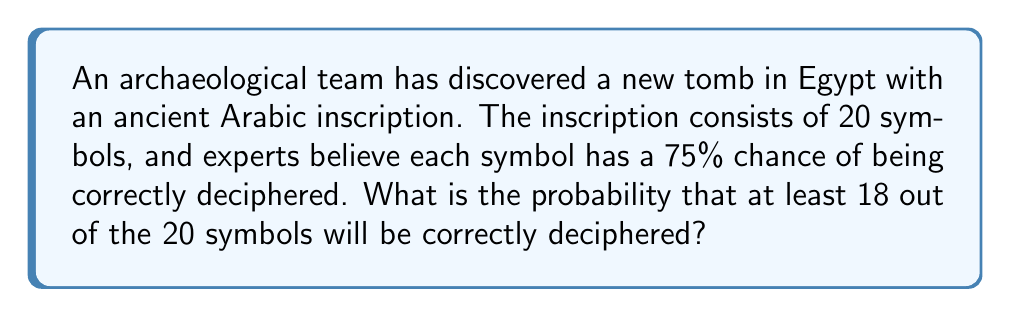Can you answer this question? To solve this problem, we'll use the binomial probability distribution, as we're dealing with a fixed number of independent trials (deciphering each symbol) with two possible outcomes (success or failure).

Let's break it down step-by-step:

1. We have $n = 20$ symbols (trials)
2. The probability of success (correctly deciphering a symbol) is $p = 0.75$
3. We want to find the probability of at least 18 successes, which means we need to calculate $P(X \geq 18)$, where $X$ is the number of correctly deciphered symbols

We can calculate this as:

$P(X \geq 18) = P(X = 18) + P(X = 19) + P(X = 20)$

Using the binomial probability formula:

$P(X = k) = \binom{n}{k} p^k (1-p)^{n-k}$

Where $\binom{n}{k}$ is the binomial coefficient, calculated as:

$\binom{n}{k} = \frac{n!}{k!(n-k)!}$

Let's calculate each probability:

For $k = 18$:
$$P(X = 18) = \binom{20}{18} (0.75)^{18} (0.25)^2 = 190 \times 0.75^{18} \times 0.25^2 \approx 0.2252$$

For $k = 19$:
$$P(X = 19) = \binom{20}{19} (0.75)^{19} (0.25)^1 = 20 \times 0.75^{19} \times 0.25 \approx 0.1001$$

For $k = 20$:
$$P(X = 20) = \binom{20}{20} (0.75)^{20} (0.25)^0 = 1 \times 0.75^{20} \approx 0.0032$$

Now, we sum these probabilities:

$P(X \geq 18) = 0.2252 + 0.1001 + 0.0032 \approx 0.3285$

Therefore, the probability of correctly deciphering at least 18 out of 20 symbols is approximately 0.3285 or 32.85%.
Answer: $0.3285$ or $32.85\%$ 